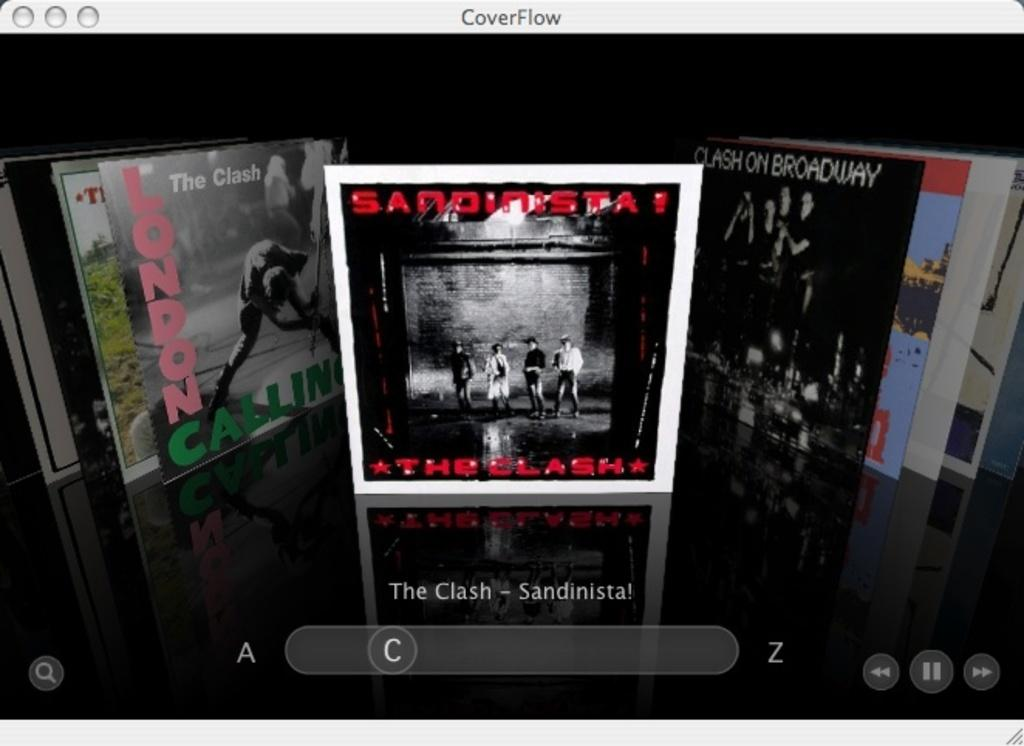<image>
Describe the image concisely. Album cover for The Clash titled Sandisita showing four people standing there. 